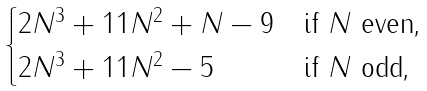<formula> <loc_0><loc_0><loc_500><loc_500>\begin{cases} 2 N ^ { 3 } + 1 1 N ^ { 2 } + N - 9 & \text {if $N$ even,} \\ 2 N ^ { 3 } + 1 1 N ^ { 2 } - 5 & \text {if $N$ odd,} \end{cases}</formula> 